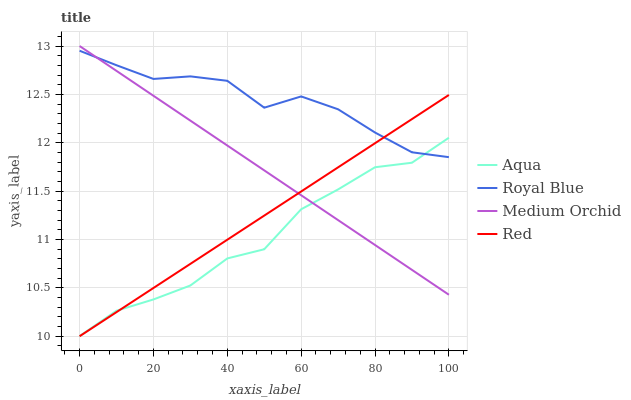Does Medium Orchid have the minimum area under the curve?
Answer yes or no. No. Does Medium Orchid have the maximum area under the curve?
Answer yes or no. No. Is Medium Orchid the smoothest?
Answer yes or no. No. Is Medium Orchid the roughest?
Answer yes or no. No. Does Medium Orchid have the lowest value?
Answer yes or no. No. Does Aqua have the highest value?
Answer yes or no. No. 